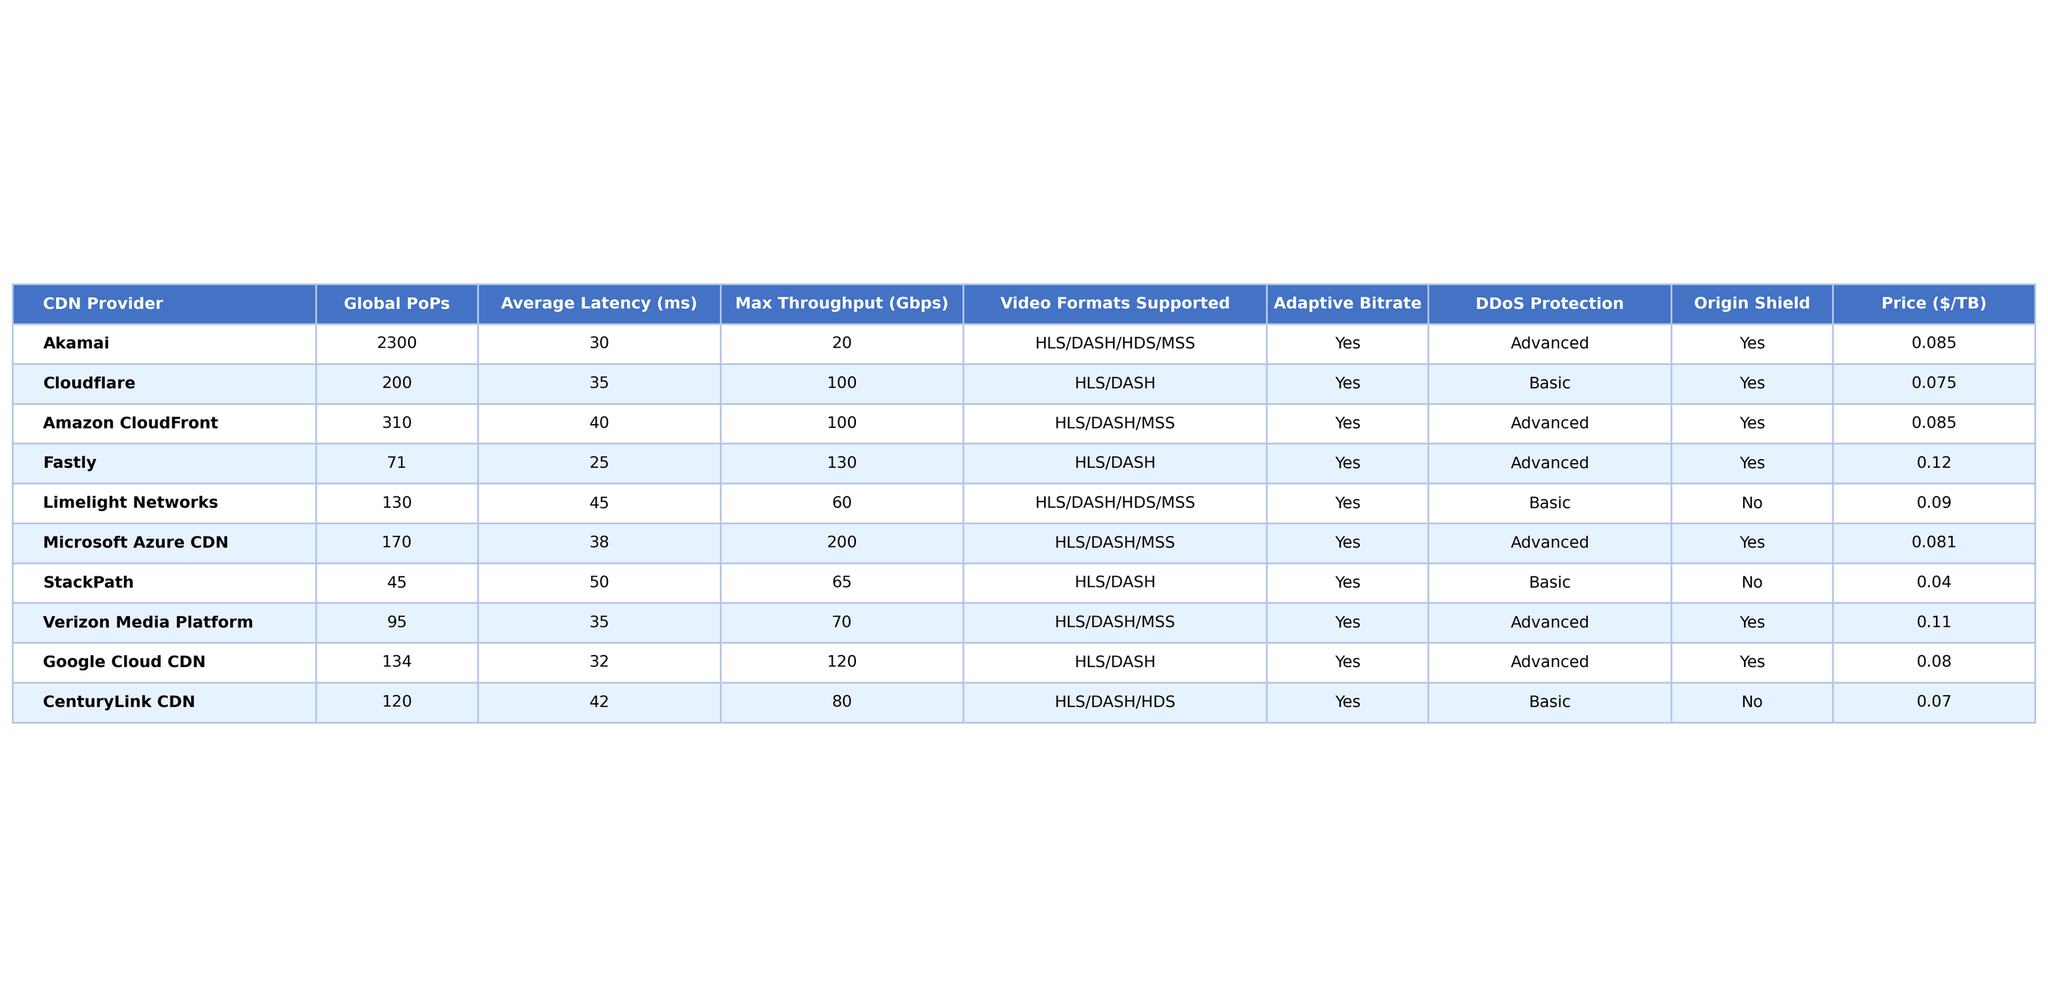What is the average latency among the CDN providers? To find the average latency, sum all the average latency values (30 + 35 + 40 + 25 + 45 + 38 + 50 + 35 + 32 + 42 = 392) and divide by the number of providers (10). Thus, the average latency is 392 / 10 = 39.2 ms.
Answer: 39.2 ms Which CDN provider has the highest maximum throughput? By examining the "Max Throughput" column, Fastly has the highest maximum throughput value of 130 Gbps.
Answer: Fastly Do all CDN providers support Adaptive Bitrate streaming? A quick review of the "Adaptive Bitrate" column shows that all providers marked "Yes" for Adaptive Bitrate, indicating they all support it.
Answer: Yes Which CDN provider has the most global points of presence (PoPs)? Looking at the "Global PoPs" column, Akamai has the highest value of 2300 PoPs.
Answer: Akamai Is there a CDN provider that offers both Advanced DDoS Protection and Origin Shield? The "DDoS Protection" column for Akamai, Amazon CloudFront, Microsoft Azure CDN, Fastly, and Verizon Media Platform shows "Advanced," while the "Origin Shield" column indicates that both Akamai and Amazon CloudFront offer it. Hence, these two meet the criteria.
Answer: Yes, Akamai and Amazon CloudFront What is the price difference per TB between StackPath and Limelight Networks? The price for StackPath is $0.04/TB and for Limelight Networks is $0.09/TB. The difference is $0.09 - $0.04 = $0.05 per TB.
Answer: $0.05 Which CDN provider offers the least expensive service and what is the price? The lowest price per TB is found in the "Price" column for StackPath, which is $0.04/TB.
Answer: $0.04 Calculate the average maximum throughput of all CDN providers supporting HLS/DASH. The providers supporting HLS/DASH are Cloudflare, Amazon CloudFront, Fastly, Microsoft Azure CDN, Google Cloud CDN, and CenturyLink CDN. Their maximum throughputs are (100 + 100 + 130 + 200 + 120 + 80 = 730) Gbps total from 6 providers, hence the average is 730 / 6 = 121.67 Gbps.
Answer: 121.67 Gbps Which CDN provider has the longest average latency, and what is that latency? By checking the "Average Latency" column, Limelight Networks has the longest latency, which is 45 ms.
Answer: Limelight Networks, 45 ms What percentage of the CDN providers provide Advanced DDoS Protection? Out of 10 providers, 5 offer Advanced DDoS Protection. The percentage is (5/10) * 100 = 50%.
Answer: 50% 